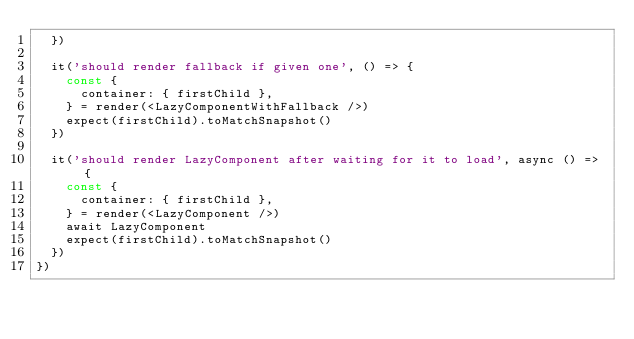<code> <loc_0><loc_0><loc_500><loc_500><_JavaScript_>  })

  it('should render fallback if given one', () => {
    const {
      container: { firstChild },
    } = render(<LazyComponentWithFallback />)
    expect(firstChild).toMatchSnapshot()
  })

  it('should render LazyComponent after waiting for it to load', async () => {
    const {
      container: { firstChild },
    } = render(<LazyComponent />)
    await LazyComponent
    expect(firstChild).toMatchSnapshot()
  })
})
</code> 